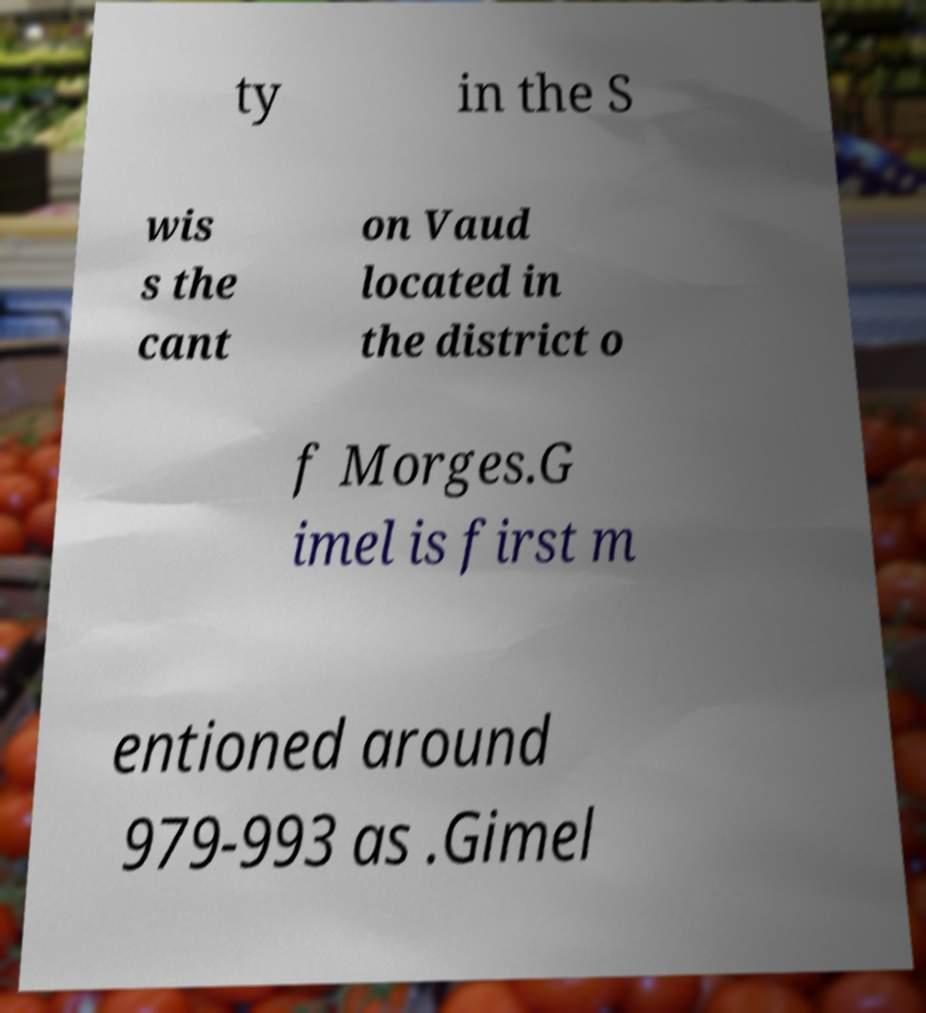Could you extract and type out the text from this image? ty in the S wis s the cant on Vaud located in the district o f Morges.G imel is first m entioned around 979-993 as .Gimel 